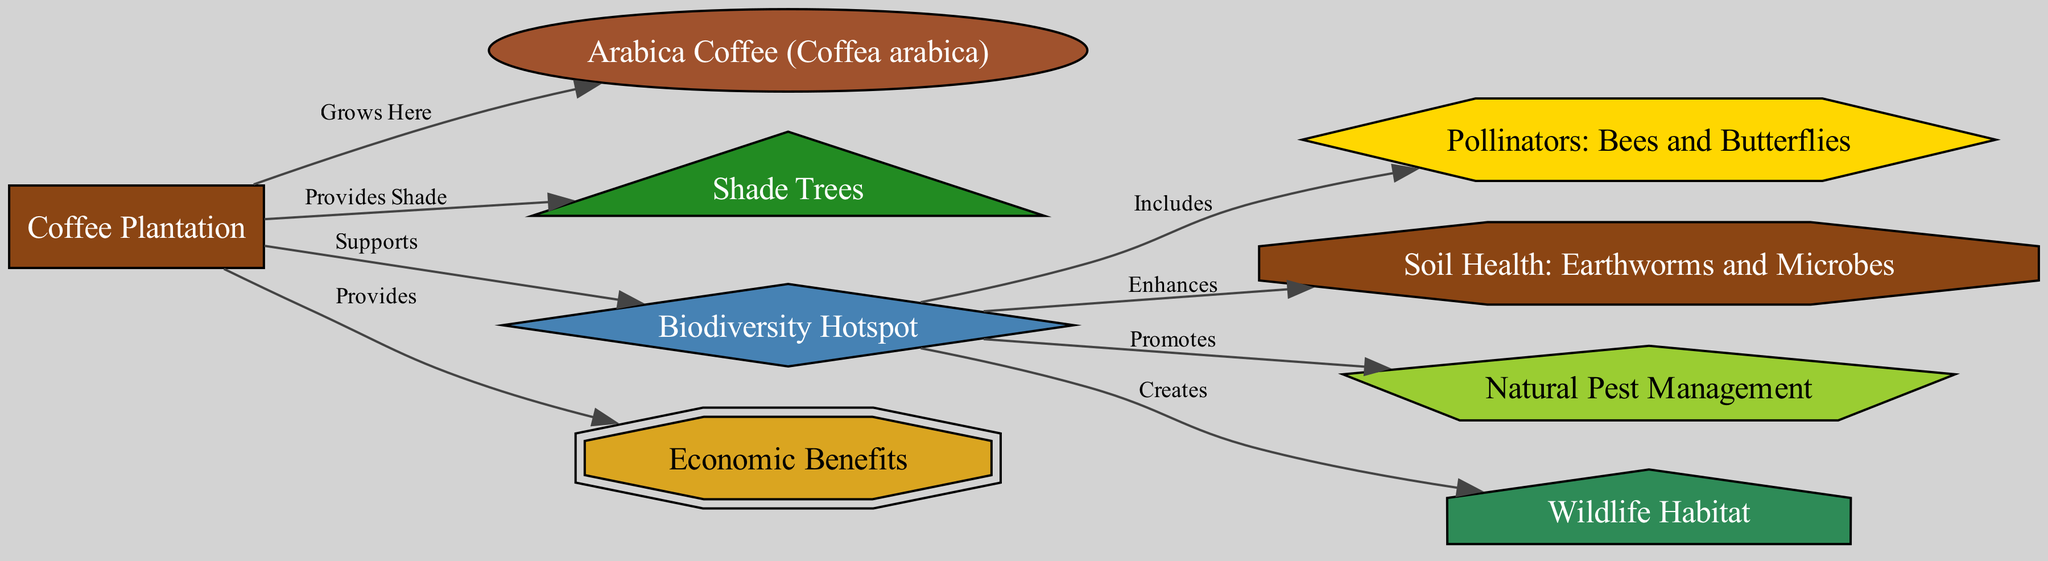What is the main type of coffee grown in the plantation? The diagram explicitly labels "Arabica Coffee (Coffea arabica)" as an element connected to the "Coffee Plantation" node through "Grows Here". Therefore, this clearly indicates that Arabica is the main type grown there.
Answer: Arabica Coffee How many nodes are present in the diagram? By counting the nodes listed in the diagram, there are nine distinct nodes that represent various components of the coffee plantation ecosystem.
Answer: Nine What benefits does biodiversity provide? The node "Biodiversity Hotspot" has arrows pointing to multiple nodes, indicating the benefits it provides, including "Pollinators", "Soil Health", "Natural Pest Management", and "Wildlife Habitat".
Answer: Pollinators, Soil Health, Natural Pest Management, Wildlife Habitat What do shade trees provide in this ecosystem? The diagram connects "Shade Trees" to "Coffee Plantation" with the label "Provides Shade", indicating that shade trees are beneficial for shading the coffee plants.
Answer: Shade Which elements are related to pest management in this diagram? The "Biodiversity Hotspot" promotes "Natural Pest Management", as indicated by the edge labeled "Promotes" between these two nodes. This shows that biodiversity is a key factor in pest management.
Answer: Natural Pest Management What creates a wildlife habitat according to the diagram? The diagram illustrates that the "Biodiversity Hotspot" creates a "Wildlife Habitat", as shown by the arrow labeled "Creates" linking these two nodes.
Answer: Biodiversity Hotspot What is one of the economic outcomes of the coffee plantation? The diagram states that the coffee plantation "Provides" economic benefits, indicating a direct relationship between the plantation and the economic aspects presented.
Answer: Economic Benefits 